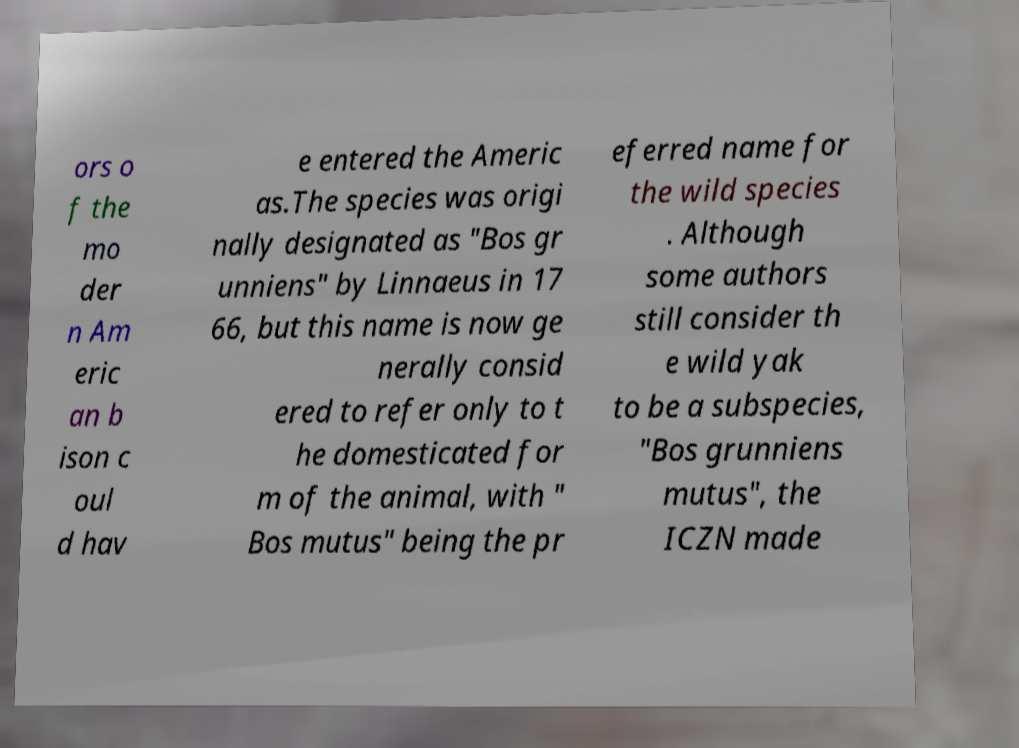Could you assist in decoding the text presented in this image and type it out clearly? ors o f the mo der n Am eric an b ison c oul d hav e entered the Americ as.The species was origi nally designated as "Bos gr unniens" by Linnaeus in 17 66, but this name is now ge nerally consid ered to refer only to t he domesticated for m of the animal, with " Bos mutus" being the pr eferred name for the wild species . Although some authors still consider th e wild yak to be a subspecies, "Bos grunniens mutus", the ICZN made 